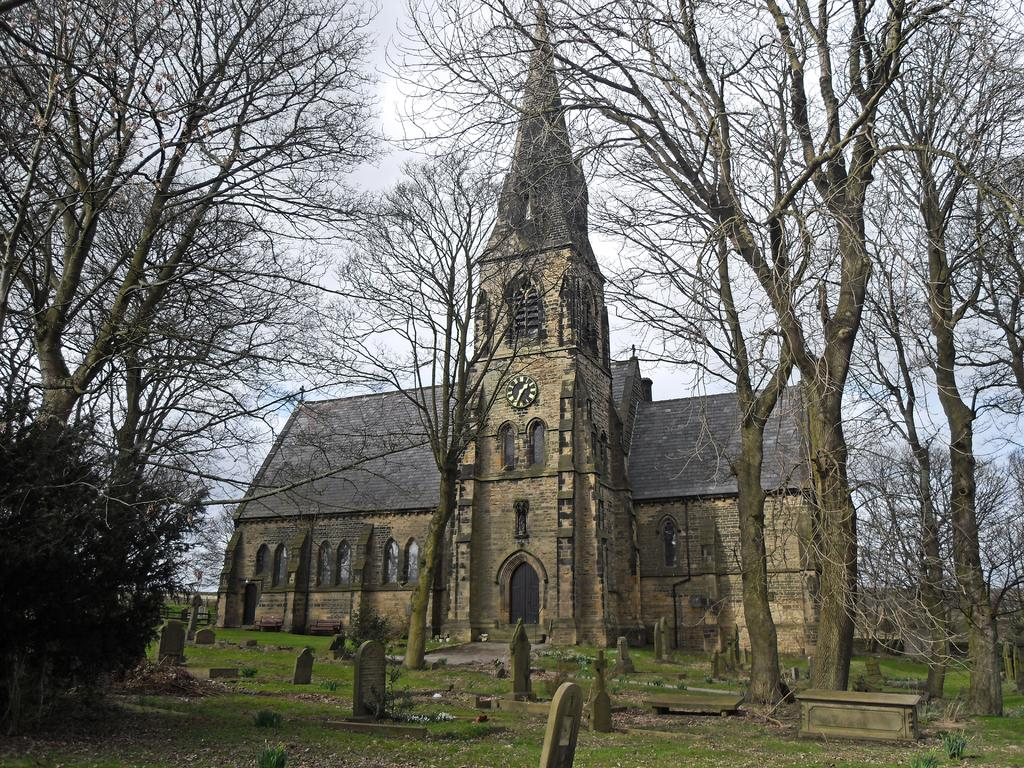What type of structure is visible in the image? There is a building in the image. What features can be seen on the building? The building has windows and doors. What time-telling device is present in the building? There is a wall clock in the building. What is located in front of the building? There is a graveyard and trees in front of the building. What can be seen in the background of the image? The sky is visible in the background of the image. What type of juice is being served at the funeral in the image? There is no indication of a funeral or juice being served in the image. The image only shows a building with a graveyard and trees in front of it. 